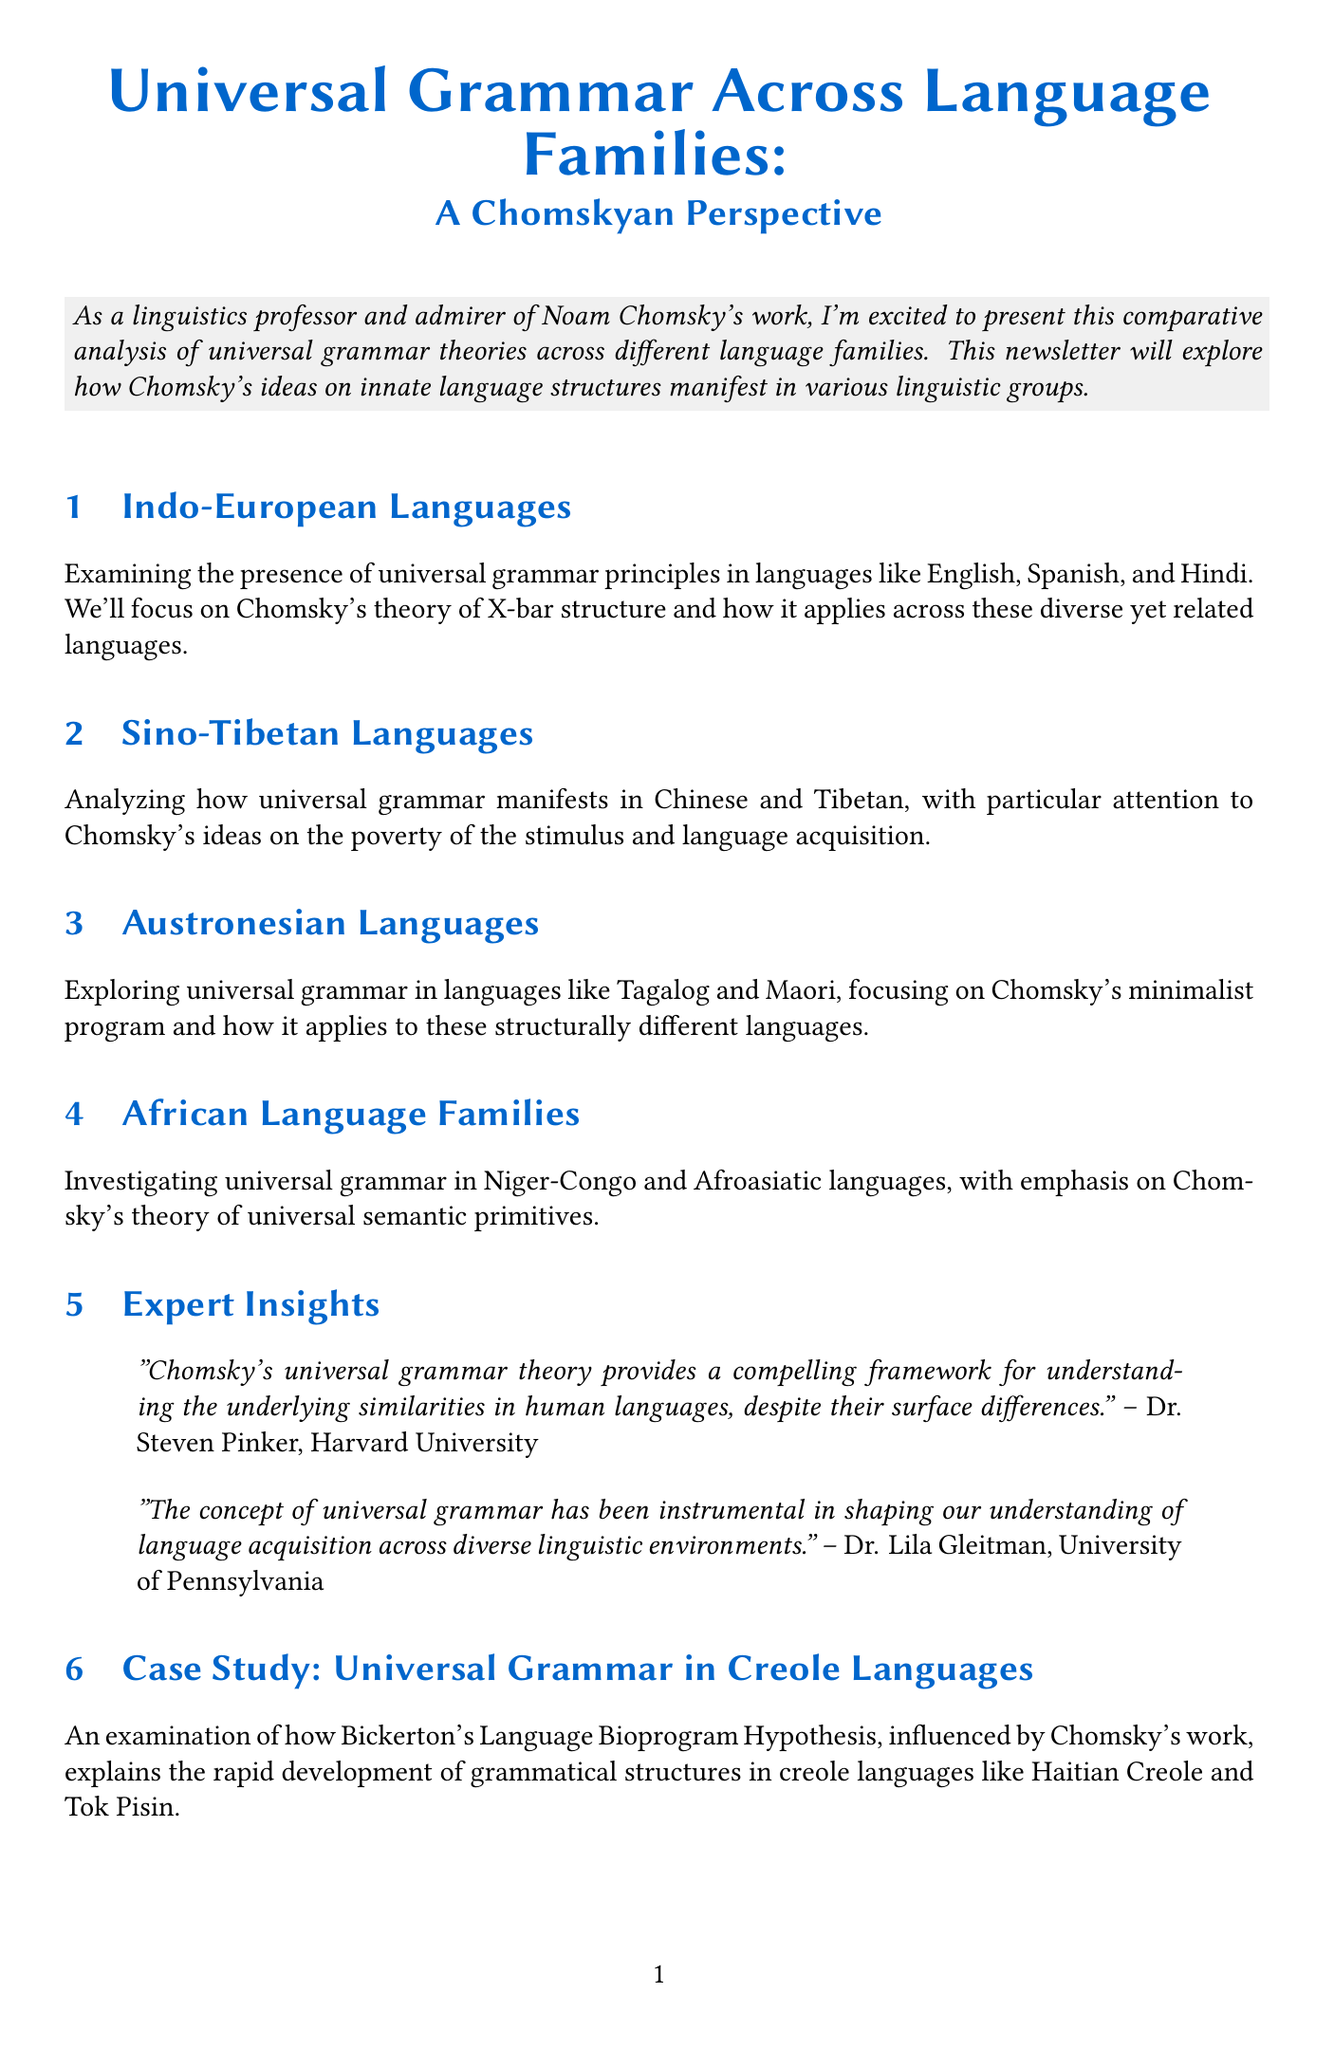What is the newsletter title? The newsletter title is stated at the beginning of the document.
Answer: Universal Grammar Across Language Families: A Chomskyan Perspective Who is quoted from Harvard University? The document includes quotes from experts, which specify their affiliations.
Answer: Dr. Steven Pinker Which languages are analyzed under the Sino-Tibetan section? The section mentions specific languages being analyzed in the content.
Answer: Chinese and Tibetan What theory is discussed in relation to Austronesian languages? The content mentions a specific Chomskyan theory associated with Austronesian languages.
Answer: minimalist program What type of languages are examined in the case study? The case study specifies the type of languages being examined.
Answer: Creole languages Which two languages are compared in the infographic for African language families? The infographic illustrates shared semantic primitives between specific languages.
Answer: Swahili and Arabic What does Chomsky's theory of universal grammar focus on? The introduction and conclusion summarize the focus of Chomsky's theory throughout the newsletter.
Answer: innate language structures What is the name of the hypothesis discussed in the case study? The case study explicitly mentions a hypothesis related to language development.
Answer: Language Bioprogram Hypothesis 